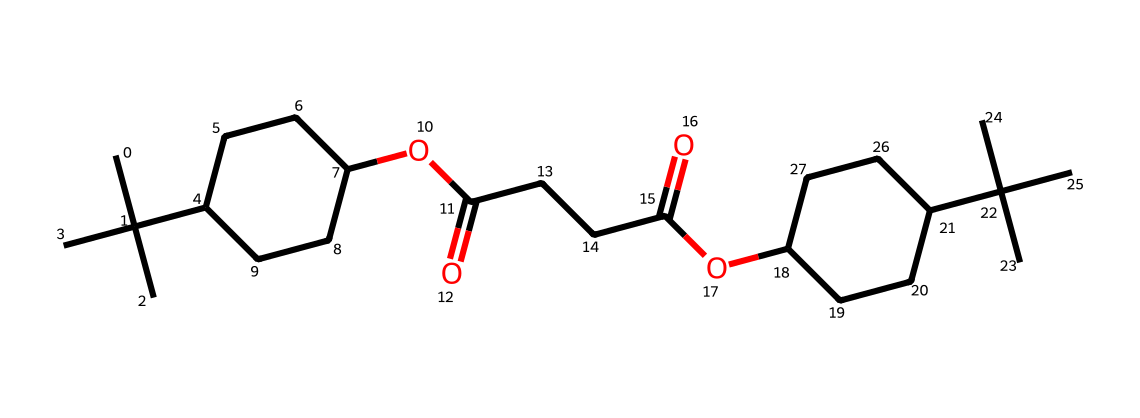how many carbon atoms are in this chemical? To find the number of carbon atoms, we need to count the 'C' symbols in the SMILES representation. Each 'C' stands for one carbon atom. There are 25 instances of 'C' in the SMILES structure.
Answer: 25 what type of functional group is present in this chemical? By analyzing the structure, we can identify 'OC(=O)' and 'C(=O)O' patterns, which are indicative of ester functional groups. The presence of carbonyl (C=O) and ester (–O–) structures confirms this.
Answer: ester how many cyclic structures are shown in the chemical? The analysis of the SMILES notation indicates the presence of rings through the 'C1' and 'C2' designations, indicating two cyclic structures. Each paired digit represents a cycle that starts and closes with that number.
Answer: 2 is this chemical likely to be hydrophilic or hydrophobic? The presence of long hydrocarbon chains suggests that the molecule predominantly consists of non-polar sections which tend to repel water. While there is an ester group which may provide slight polarity, the overall structure indicates it leans more towards hydrophobic characteristics.
Answer: hydrophobic what is the molecular weight of this chemical? To obtain molecular weight, one typically sums the weights of all atoms in the molecule using a standard periodic table. For this chemical, after calculating weights based on 25 carbons, 44 hydrogens, and 4 oxygens, the molecular weight is approximately 386.6 g/mol.
Answer: 386.6 does this chemical have surfactant properties? Surfactants typically contain both hydrophilic and hydrophobic regions to reduce surface tension. Given the structure has long carbon chains (hydrophobic) and presents ester functional groups, it is reasonable to conclude that it exhibits surfactant properties.
Answer: yes 